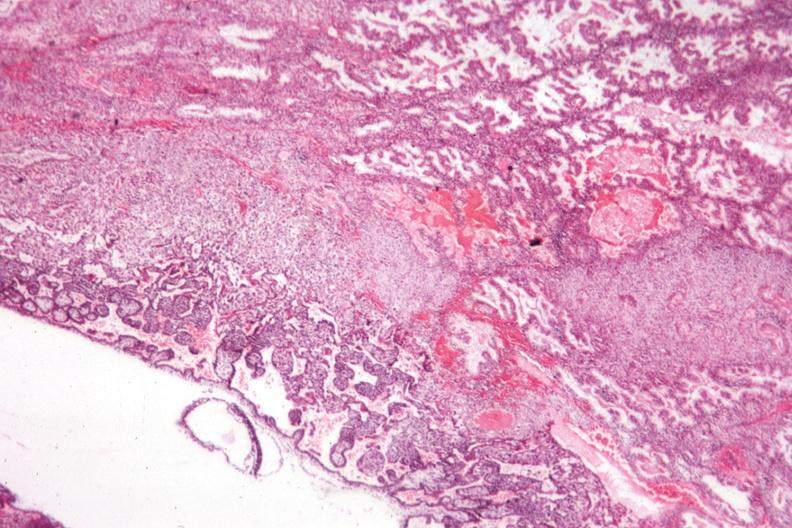s glomerulosa present?
Answer the question using a single word or phrase. No 